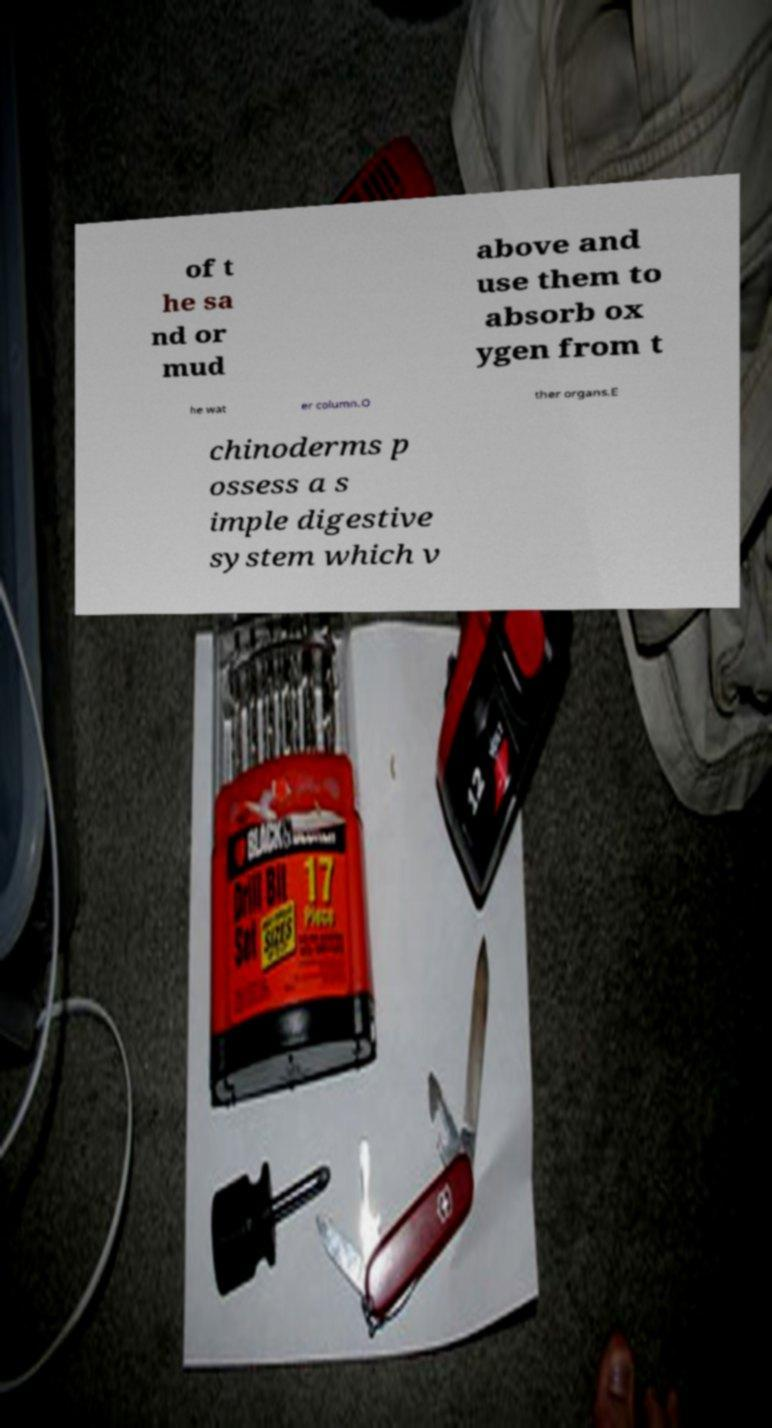Please identify and transcribe the text found in this image. of t he sa nd or mud above and use them to absorb ox ygen from t he wat er column.O ther organs.E chinoderms p ossess a s imple digestive system which v 